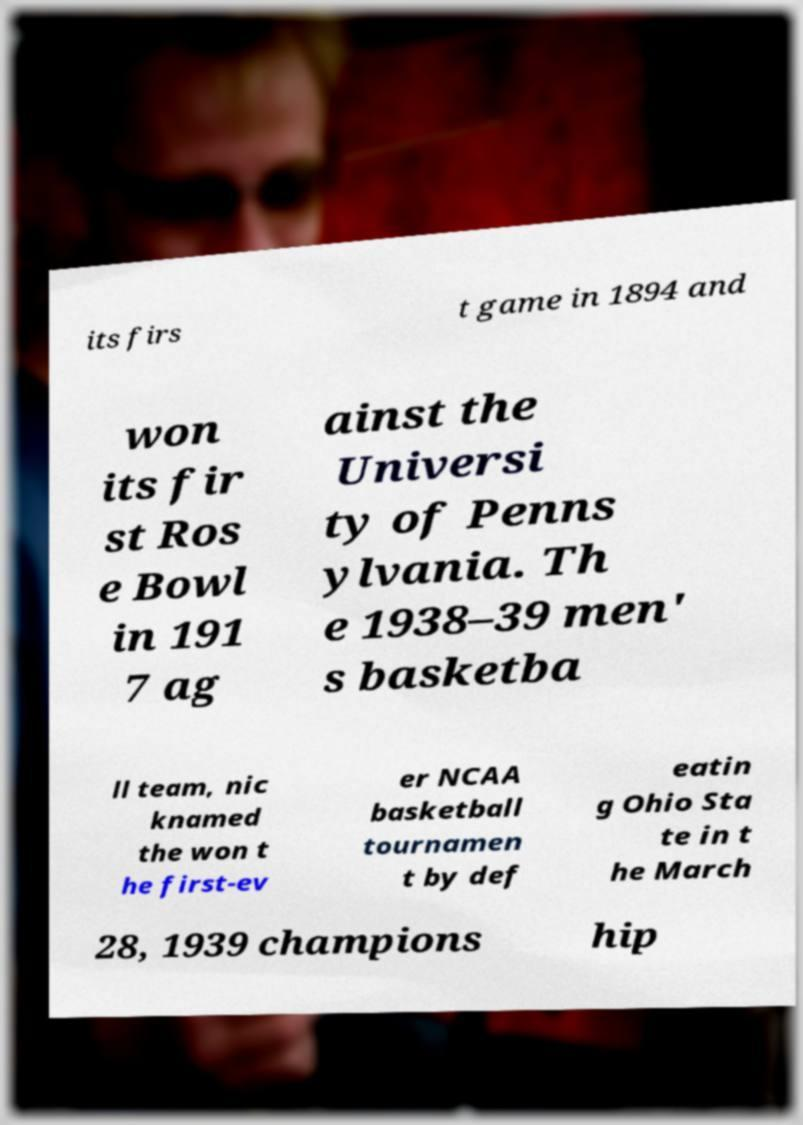For documentation purposes, I need the text within this image transcribed. Could you provide that? its firs t game in 1894 and won its fir st Ros e Bowl in 191 7 ag ainst the Universi ty of Penns ylvania. Th e 1938–39 men' s basketba ll team, nic knamed the won t he first-ev er NCAA basketball tournamen t by def eatin g Ohio Sta te in t he March 28, 1939 champions hip 